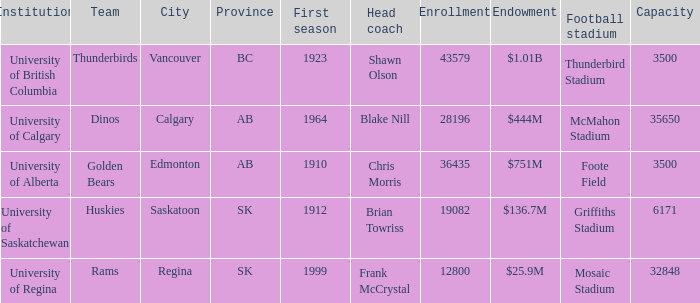How many endowments does Mosaic Stadium have? 1.0. 